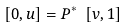<formula> <loc_0><loc_0><loc_500><loc_500>[ 0 , u ] = P ^ { * } \ [ v , 1 ]</formula> 